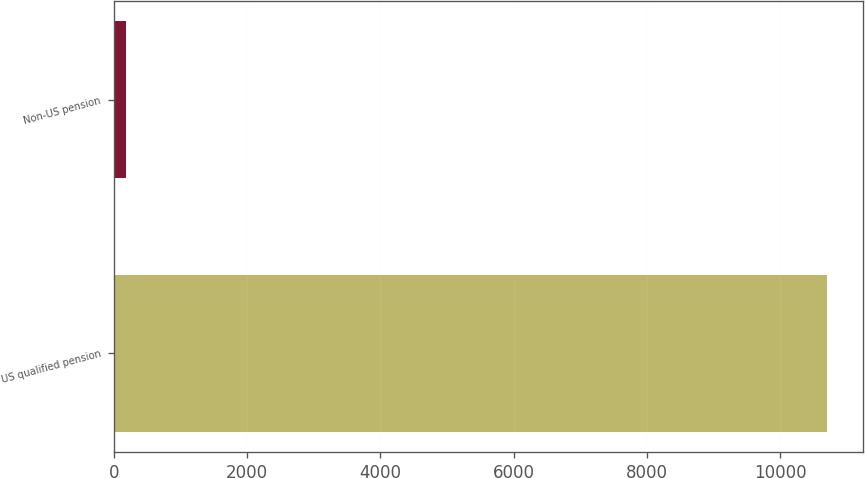<chart> <loc_0><loc_0><loc_500><loc_500><bar_chart><fcel>US qualified pension<fcel>Non-US pension<nl><fcel>10706<fcel>181<nl></chart> 